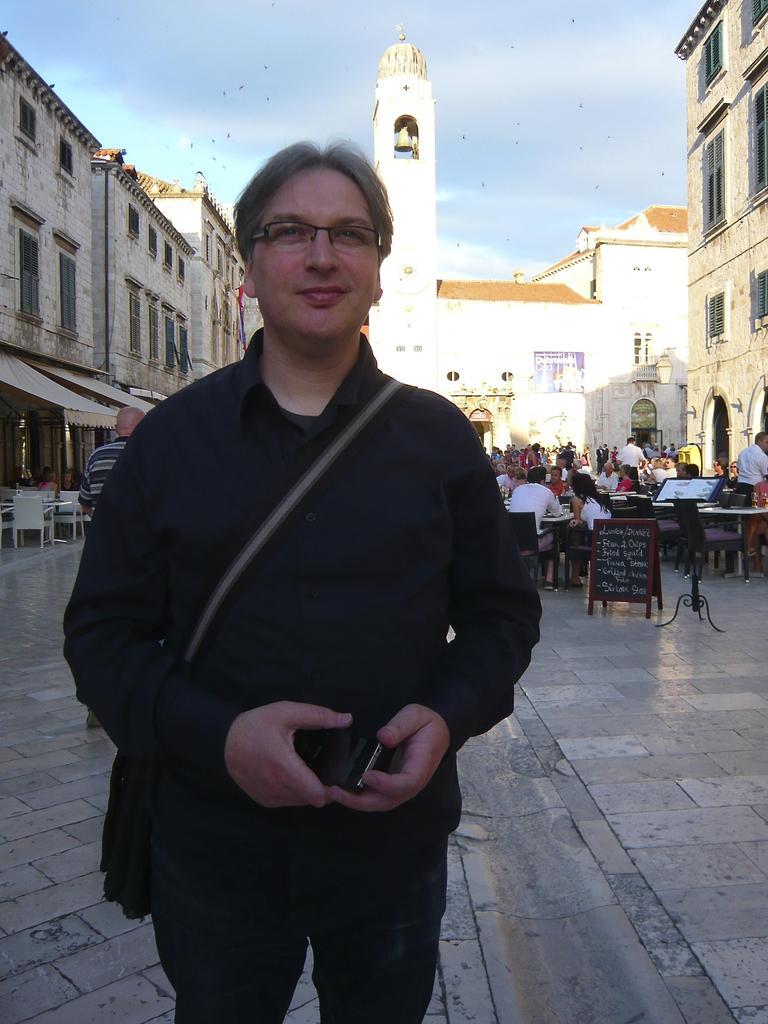Please provide a concise description of this image. This picture is clicked outside the city. The man in front of the picture wearing a black jacket is standing. He is holding a mobile phone in his hands and he is smiling. Behind him, we see many people are sitting on the chairs around the table. On the right side, we see a board in brown color with some text written on it. On the left side, we see the chairs. There are buildings and a tower in the background. At the top of the picture, we see the sky and the birds are flying in the sky. 